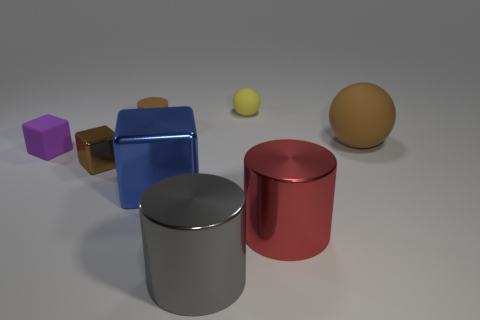Add 2 small gray matte balls. How many objects exist? 10 Subtract all blocks. How many objects are left? 5 Add 7 purple things. How many purple things exist? 8 Subtract 0 blue spheres. How many objects are left? 8 Subtract all shiny objects. Subtract all big things. How many objects are left? 0 Add 5 big gray objects. How many big gray objects are left? 6 